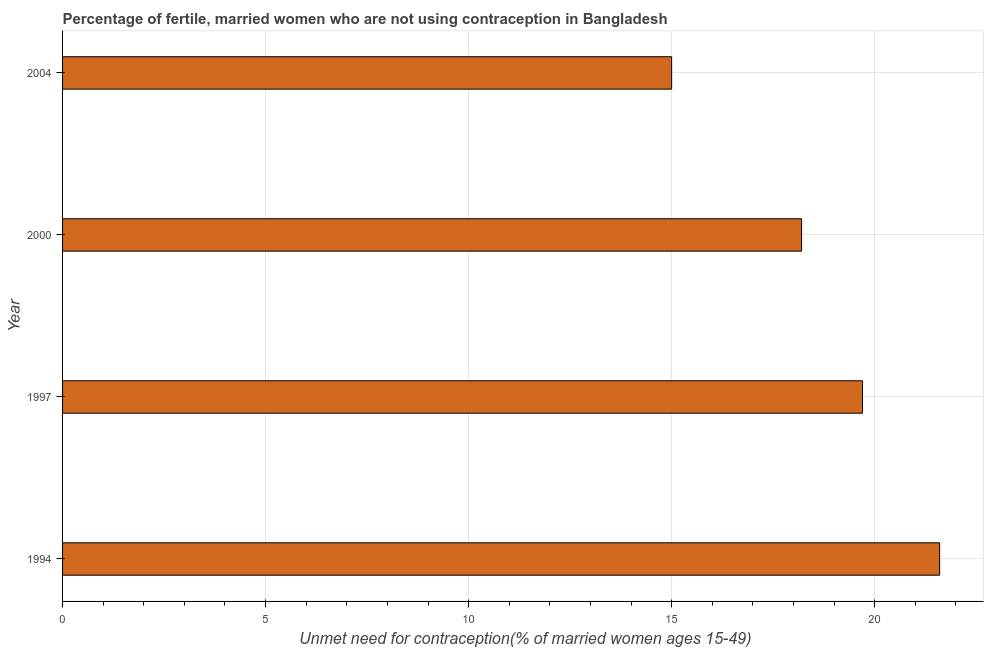What is the title of the graph?
Your answer should be very brief. Percentage of fertile, married women who are not using contraception in Bangladesh. What is the label or title of the X-axis?
Ensure brevity in your answer.   Unmet need for contraception(% of married women ages 15-49). What is the number of married women who are not using contraception in 2004?
Provide a short and direct response. 15. Across all years, what is the maximum number of married women who are not using contraception?
Provide a succinct answer. 21.6. In which year was the number of married women who are not using contraception maximum?
Offer a very short reply. 1994. What is the sum of the number of married women who are not using contraception?
Your response must be concise. 74.5. What is the average number of married women who are not using contraception per year?
Your answer should be very brief. 18.62. What is the median number of married women who are not using contraception?
Your response must be concise. 18.95. What is the ratio of the number of married women who are not using contraception in 1997 to that in 2004?
Provide a succinct answer. 1.31. Is the number of married women who are not using contraception in 1994 less than that in 1997?
Provide a succinct answer. No. Is the difference between the number of married women who are not using contraception in 2000 and 2004 greater than the difference between any two years?
Offer a very short reply. No. Is the sum of the number of married women who are not using contraception in 2000 and 2004 greater than the maximum number of married women who are not using contraception across all years?
Ensure brevity in your answer.  Yes. What is the difference between the highest and the lowest number of married women who are not using contraception?
Ensure brevity in your answer.  6.6. Are all the bars in the graph horizontal?
Keep it short and to the point. Yes. How many years are there in the graph?
Your answer should be compact. 4. Are the values on the major ticks of X-axis written in scientific E-notation?
Offer a terse response. No. What is the  Unmet need for contraception(% of married women ages 15-49) of 1994?
Offer a very short reply. 21.6. What is the  Unmet need for contraception(% of married women ages 15-49) in 1997?
Your answer should be compact. 19.7. What is the difference between the  Unmet need for contraception(% of married women ages 15-49) in 1994 and 2000?
Ensure brevity in your answer.  3.4. What is the difference between the  Unmet need for contraception(% of married women ages 15-49) in 1997 and 2004?
Offer a terse response. 4.7. What is the ratio of the  Unmet need for contraception(% of married women ages 15-49) in 1994 to that in 1997?
Your answer should be very brief. 1.1. What is the ratio of the  Unmet need for contraception(% of married women ages 15-49) in 1994 to that in 2000?
Keep it short and to the point. 1.19. What is the ratio of the  Unmet need for contraception(% of married women ages 15-49) in 1994 to that in 2004?
Make the answer very short. 1.44. What is the ratio of the  Unmet need for contraception(% of married women ages 15-49) in 1997 to that in 2000?
Your answer should be compact. 1.08. What is the ratio of the  Unmet need for contraception(% of married women ages 15-49) in 1997 to that in 2004?
Your response must be concise. 1.31. What is the ratio of the  Unmet need for contraception(% of married women ages 15-49) in 2000 to that in 2004?
Give a very brief answer. 1.21. 